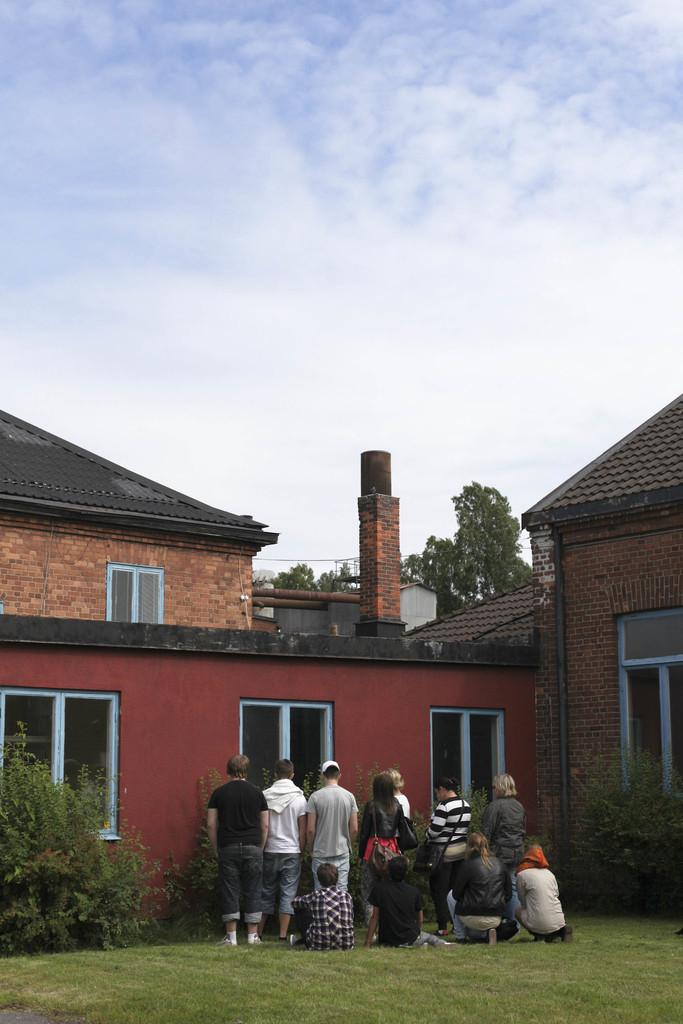What can be seen at the bottom of the image? There are people standing at the bottom of the image. What type of vegetation is on the left side of the image? There are trees on the left side of the image. What structure is located in the middle of the image? There is a house in the middle of the image. What is the condition of the sky in the image? The sky is cloudy at the top of the image. What type of iron is being used for punishment in the image? There is no iron or punishment present in the image. What cable is visible connecting the trees and the house in the image? There is no cable connecting the trees and the house in the image. 